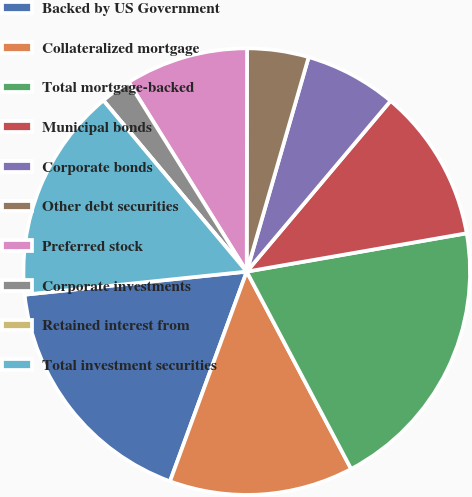Convert chart to OTSL. <chart><loc_0><loc_0><loc_500><loc_500><pie_chart><fcel>Backed by US Government<fcel>Collateralized mortgage<fcel>Total mortgage-backed<fcel>Municipal bonds<fcel>Corporate bonds<fcel>Other debt securities<fcel>Preferred stock<fcel>Corporate investments<fcel>Retained interest from<fcel>Total investment securities<nl><fcel>17.77%<fcel>13.33%<fcel>20.0%<fcel>11.11%<fcel>6.67%<fcel>4.45%<fcel>8.89%<fcel>2.23%<fcel>0.0%<fcel>15.55%<nl></chart> 